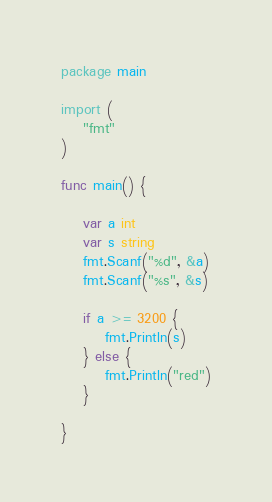Convert code to text. <code><loc_0><loc_0><loc_500><loc_500><_Go_>package main

import (
	"fmt"
)

func main() {

	var a int
	var s string
	fmt.Scanf("%d", &a)
	fmt.Scanf("%s", &s)

	if a >= 3200 {
		fmt.Println(s)
	} else {
		fmt.Println("red")
	}

}
</code> 